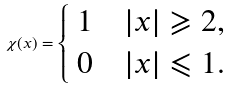<formula> <loc_0><loc_0><loc_500><loc_500>\chi ( x ) = \begin{cases} \ 1 \quad | x | \geqslant 2 , \\ \ 0 \quad | x | \leqslant 1 . \end{cases}</formula> 